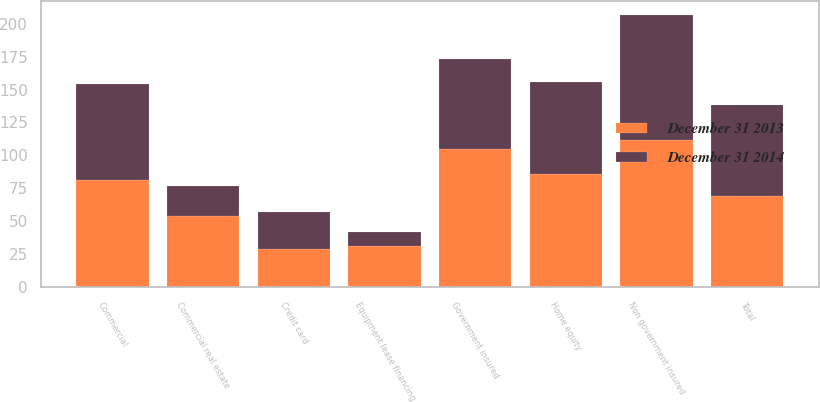Convert chart to OTSL. <chart><loc_0><loc_0><loc_500><loc_500><stacked_bar_chart><ecel><fcel>Commercial<fcel>Commercial real estate<fcel>Equipment lease financing<fcel>Home equity<fcel>Non government insured<fcel>Government insured<fcel>Credit card<fcel>Total<nl><fcel>December 31 2014<fcel>73<fcel>23<fcel>11<fcel>70<fcel>95<fcel>68<fcel>28<fcel>69<nl><fcel>December 31 2013<fcel>81<fcel>54<fcel>31<fcel>86<fcel>112<fcel>105<fcel>29<fcel>69<nl></chart> 